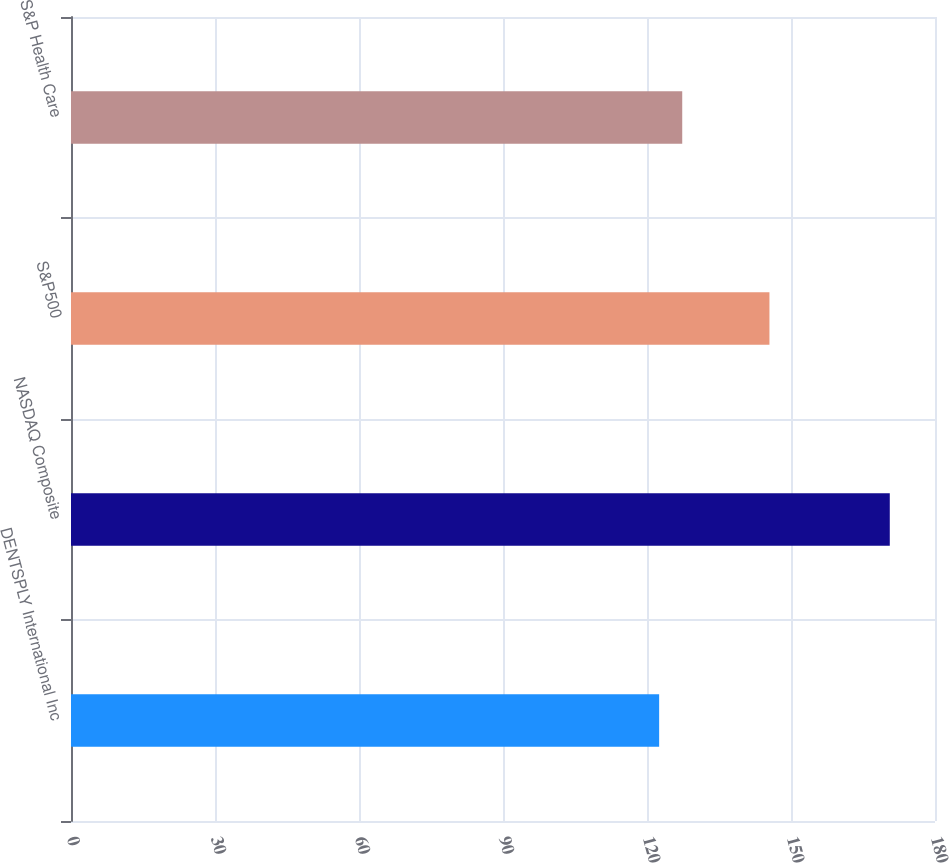Convert chart. <chart><loc_0><loc_0><loc_500><loc_500><bar_chart><fcel>DENTSPLY International Inc<fcel>NASDAQ Composite<fcel>S&P500<fcel>S&P Health Care<nl><fcel>122.53<fcel>170.58<fcel>145.51<fcel>127.34<nl></chart> 